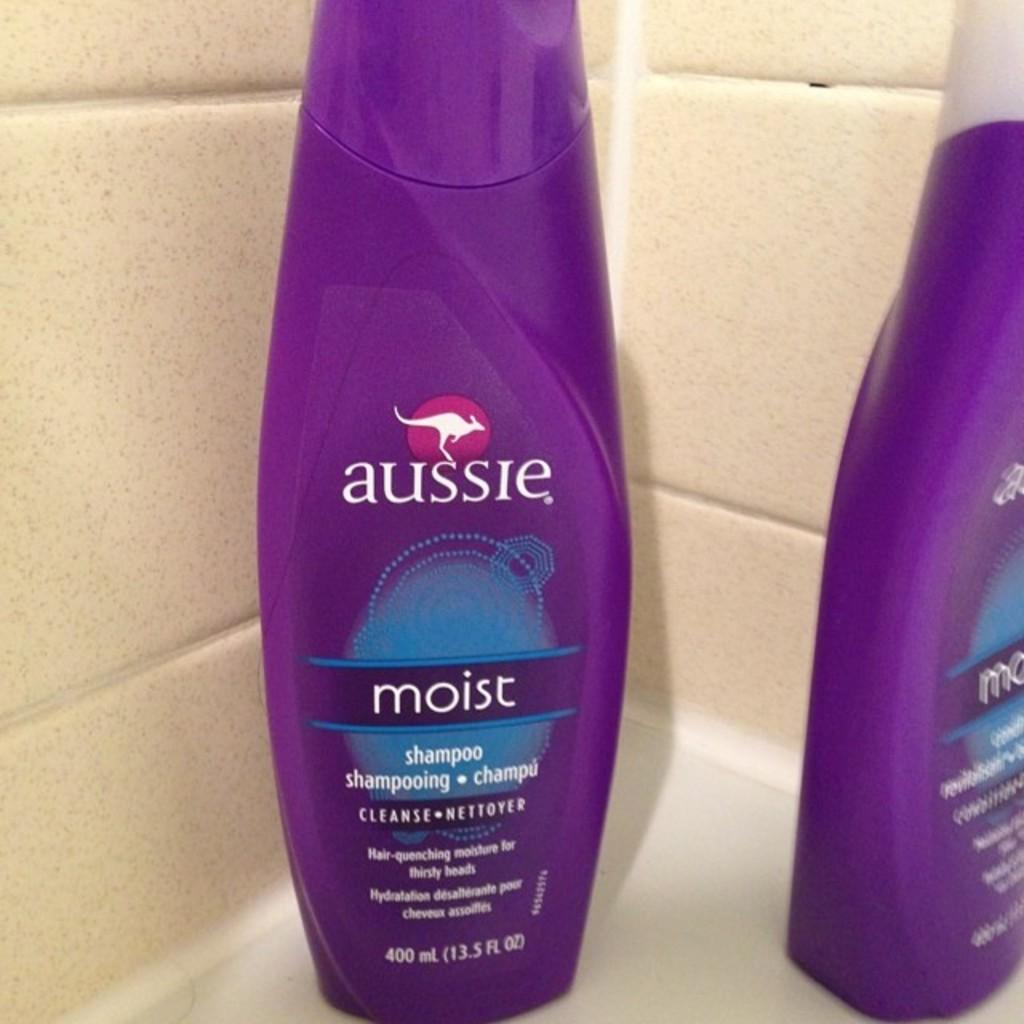<image>
Render a clear and concise summary of the photo. Two purple bottles of aussie shampoo are on the edge of a bathtub. 